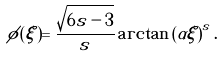<formula> <loc_0><loc_0><loc_500><loc_500>\phi ( \xi ) = \frac { \sqrt { 6 s - 3 } } { s } \arctan \left ( \alpha \xi \right ) ^ { s } .</formula> 